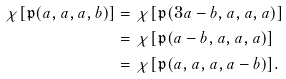<formula> <loc_0><loc_0><loc_500><loc_500>\chi [ \mathfrak { p } ( a , a , a , b ) ] & = \chi [ \mathfrak { p } ( 3 a - b , a , a , a ) ] \\ & = \chi [ \mathfrak { p } ( a - b , a , a , a ) ] \\ & = \chi [ \mathfrak { p } ( a , a , a , a - b ) ] . \\</formula> 